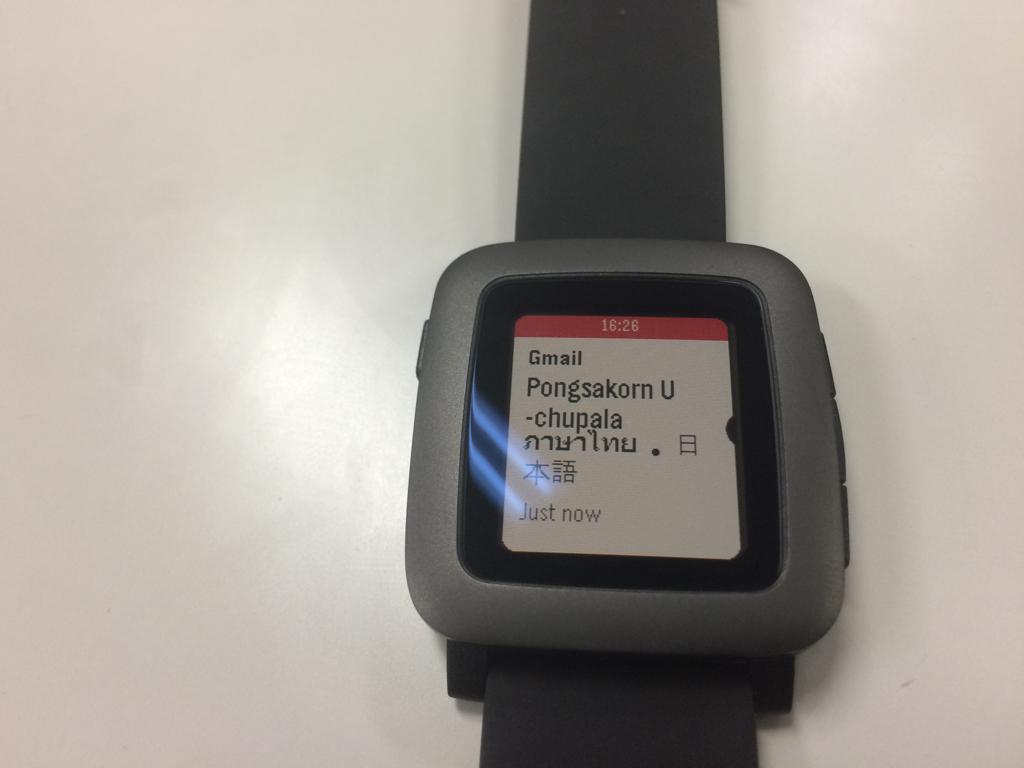What email service is on this watch?
Your answer should be very brief. Gmail. What time does the watch say it is?
Give a very brief answer. 16:26. 